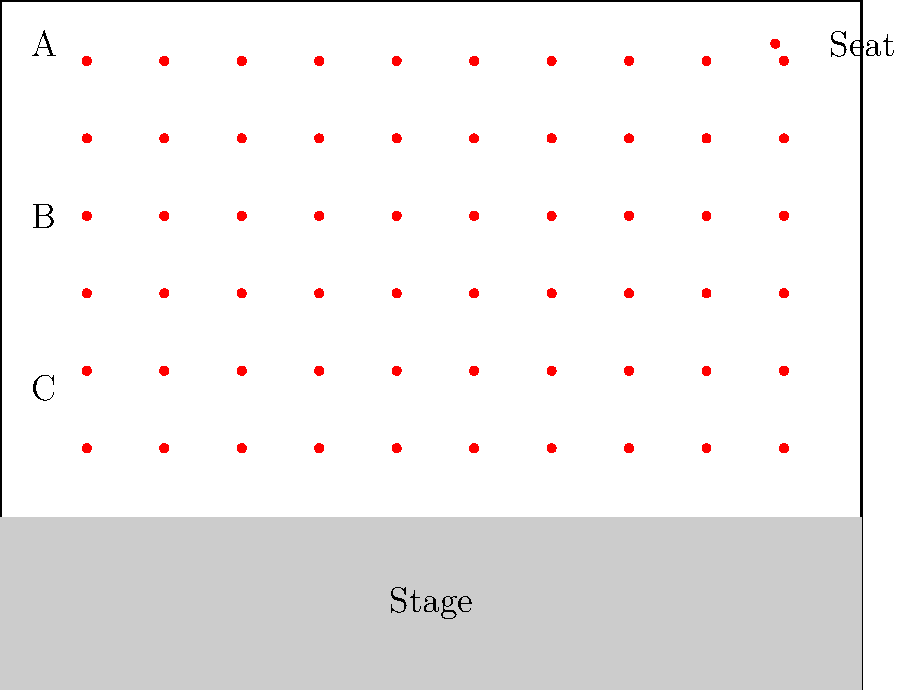Your theater has 80 seats arranged in 10 columns and 8 rows, as shown in the floor plan above. The rows are labeled A, B, and C from front to back. If the occupancy rate for a particular show is 75%, and row A is completely full, what is the minimum number of seats that must be occupied in row C? To solve this problem, let's follow these steps:

1. Calculate the total number of occupied seats:
   Total seats = 80
   Occupancy rate = 75% = 0.75
   Occupied seats = $80 \times 0.75 = 60$ seats

2. Determine the number of seats in each row:
   Seats per row = 10

3. Calculate the number of seats in rows A, B, and C:
   Row A seats = 10 (given as full)
   Rows B and C combined = $2 \times 10 = 20$ seats

4. Calculate the remaining seats to be filled:
   Remaining seats = Total occupied seats - Row A seats
   $60 - 10 = 50$ seats

5. Determine the minimum number of seats that must be occupied in row C:
   Seats to be filled in rows B and C = 50
   Maximum seats that can be filled in row B = 10
   
   Minimum seats in row C = Seats to be filled in rows B and C - Seats in row B
   $50 - 10 = 40$ seats

Therefore, the minimum number of seats that must be occupied in row C is 40.
Answer: 40 seats 